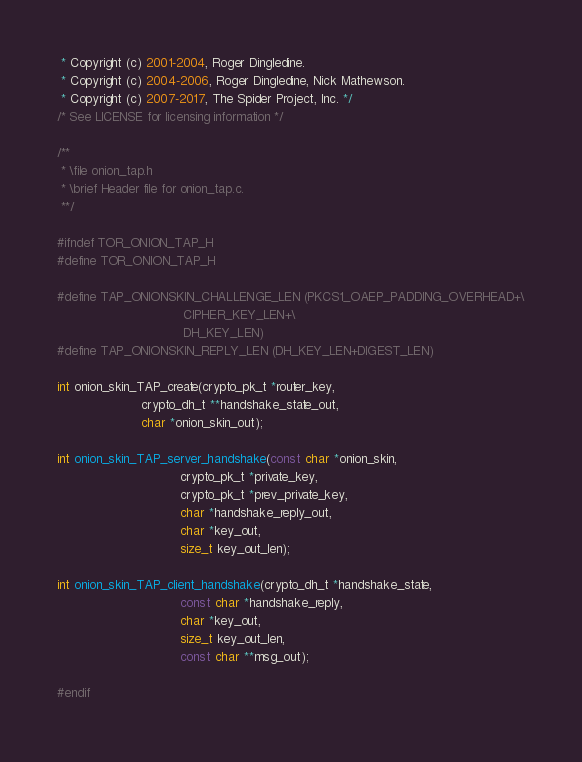<code> <loc_0><loc_0><loc_500><loc_500><_C_> * Copyright (c) 2001-2004, Roger Dingledine.
 * Copyright (c) 2004-2006, Roger Dingledine, Nick Mathewson.
 * Copyright (c) 2007-2017, The Spider Project, Inc. */
/* See LICENSE for licensing information */

/**
 * \file onion_tap.h
 * \brief Header file for onion_tap.c.
 **/

#ifndef TOR_ONION_TAP_H
#define TOR_ONION_TAP_H

#define TAP_ONIONSKIN_CHALLENGE_LEN (PKCS1_OAEP_PADDING_OVERHEAD+\
                                 CIPHER_KEY_LEN+\
                                 DH_KEY_LEN)
#define TAP_ONIONSKIN_REPLY_LEN (DH_KEY_LEN+DIGEST_LEN)

int onion_skin_TAP_create(crypto_pk_t *router_key,
                      crypto_dh_t **handshake_state_out,
                      char *onion_skin_out);

int onion_skin_TAP_server_handshake(const char *onion_skin,
                                crypto_pk_t *private_key,
                                crypto_pk_t *prev_private_key,
                                char *handshake_reply_out,
                                char *key_out,
                                size_t key_out_len);

int onion_skin_TAP_client_handshake(crypto_dh_t *handshake_state,
                                const char *handshake_reply,
                                char *key_out,
                                size_t key_out_len,
                                const char **msg_out);

#endif

</code> 